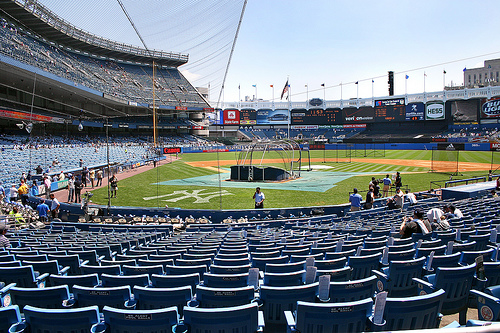<image>
Is the batting cage on the field? Yes. Looking at the image, I can see the batting cage is positioned on top of the field, with the field providing support. 